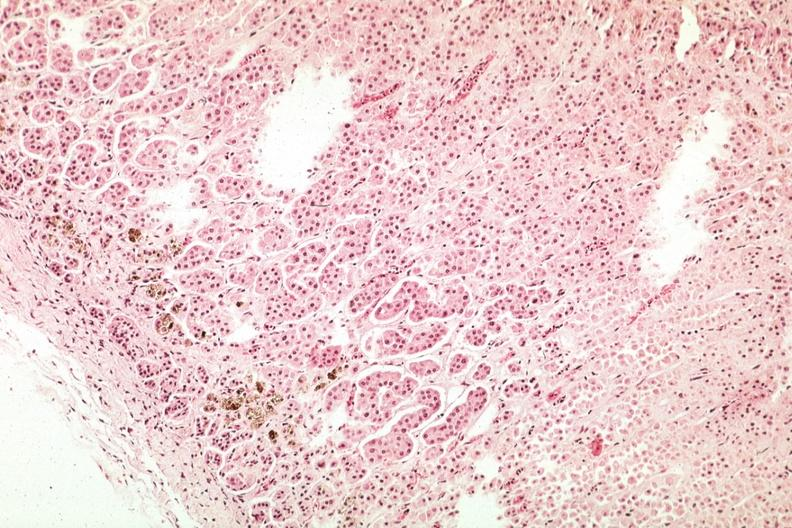what does this image show?
Answer the question using a single word or phrase. Pigment in area of zona glomerulosa 